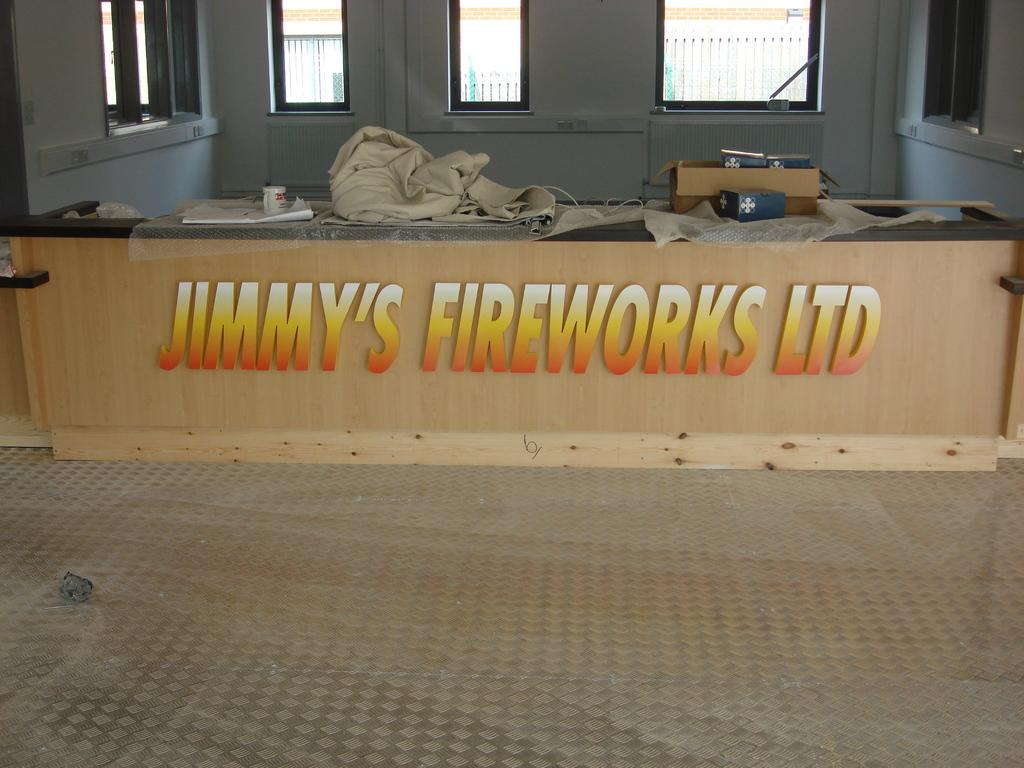What type of location is depicted in the image? The image is an inner view of a building. What can be seen on the wooden wall in the image? There is text on the wooden wall in the image. What else is visible in the image besides the wooden wall? There are objects visible in the image. What can be seen in the background of the image? There is a wall with windows in the background of the image. What color is the boy's cap in the image? There is no boy or cap present in the image. How many ice cubes are visible in the image? There is no ice visible in the image. 